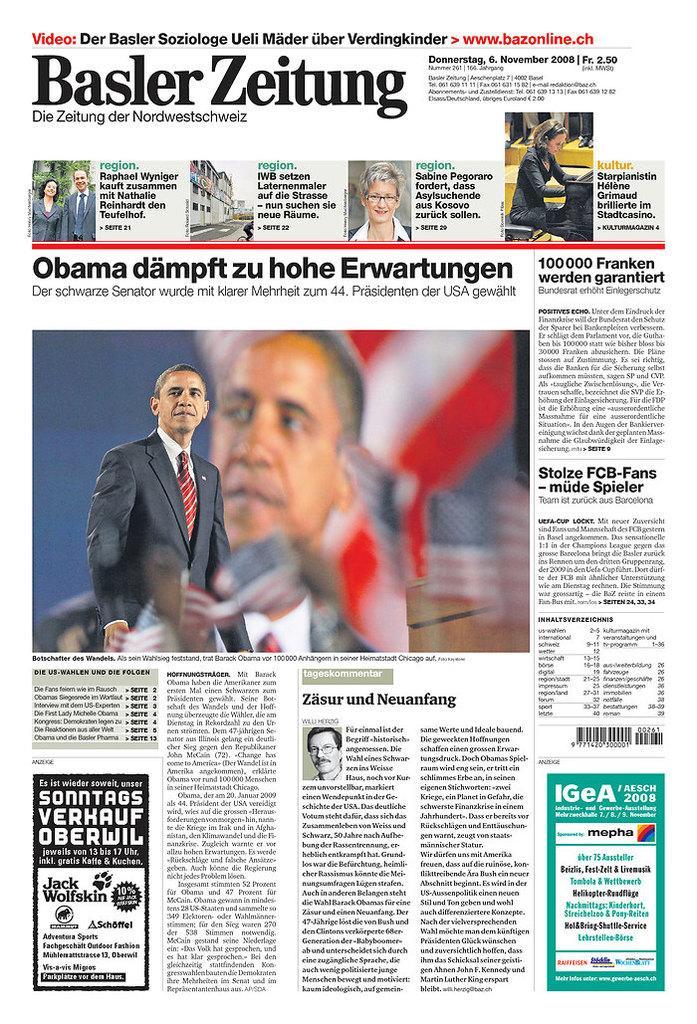Could you give a brief overview of what you see in this image? This image is of a newspaper. In this image there are persons and text. 